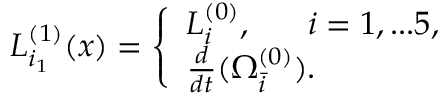<formula> <loc_0><loc_0><loc_500><loc_500>L _ { i _ { 1 } } ^ { ( 1 ) } ( x ) = \left \{ \begin{array} { l l } { { L _ { i } ^ { ( 0 ) } , \ i = 1 , \dots 5 , } } \\ { { \frac { d } { d t } ( \Omega _ { \bar { i } } ^ { ( 0 ) } ) . } } \end{array}</formula> 